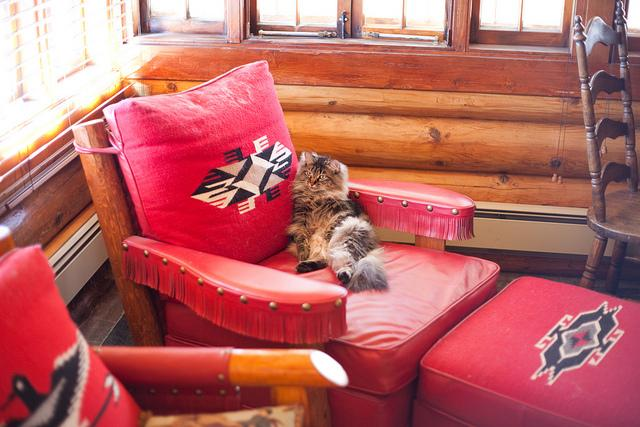What kind of walls are in this house?

Choices:
A) stone
B) plaster
C) log
D) brick log 